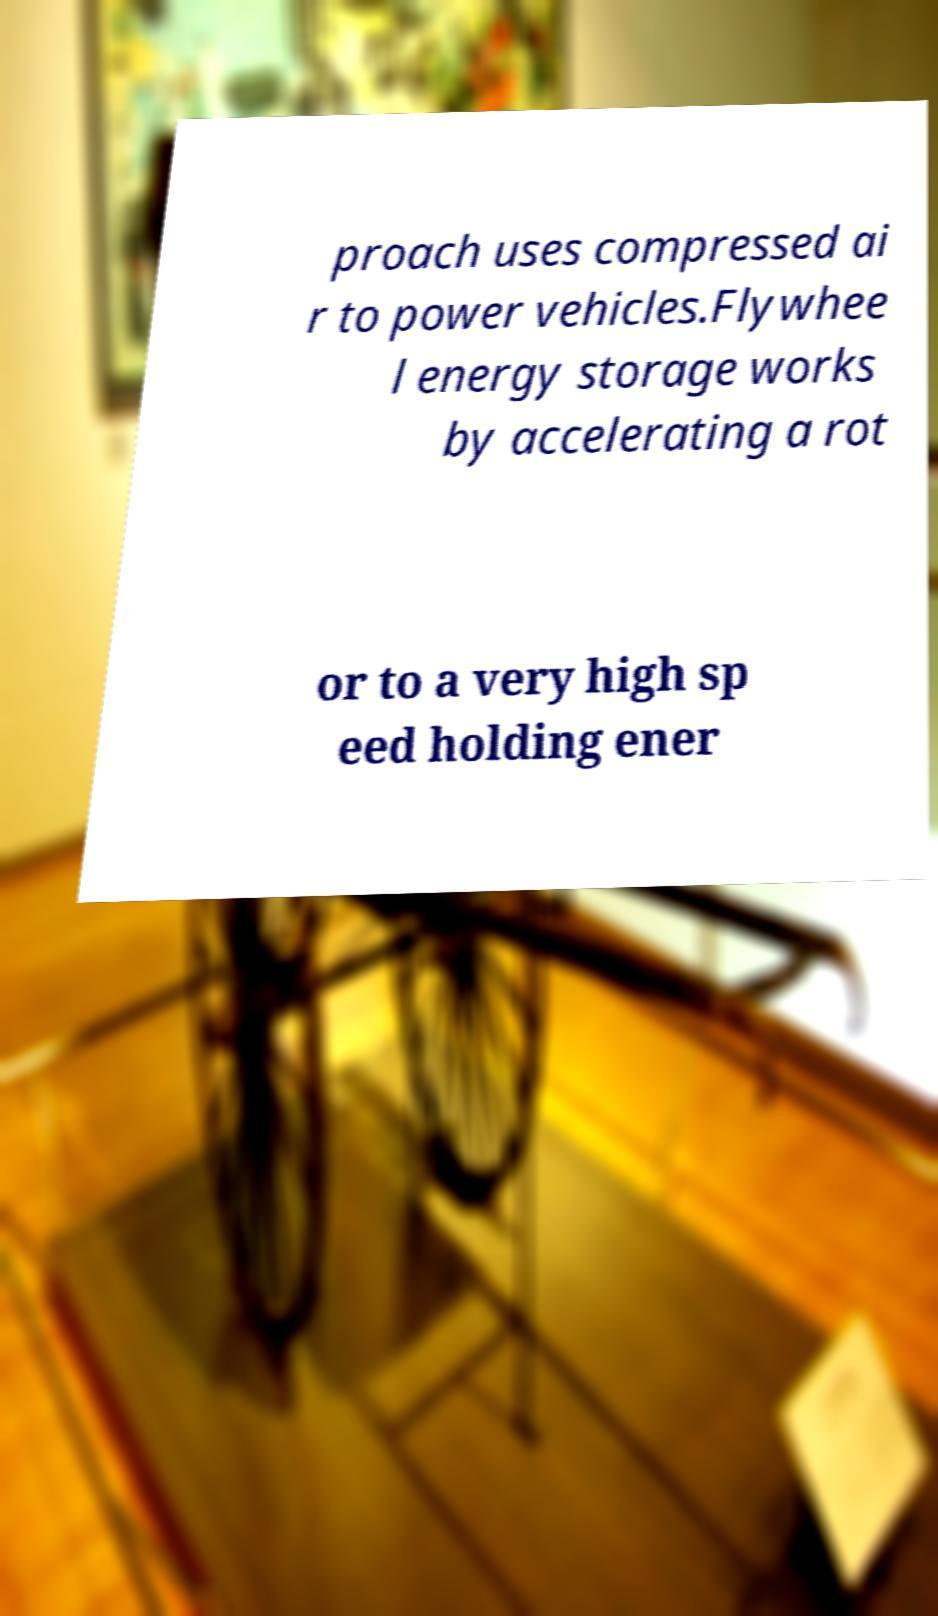Can you read and provide the text displayed in the image?This photo seems to have some interesting text. Can you extract and type it out for me? proach uses compressed ai r to power vehicles.Flywhee l energy storage works by accelerating a rot or to a very high sp eed holding ener 